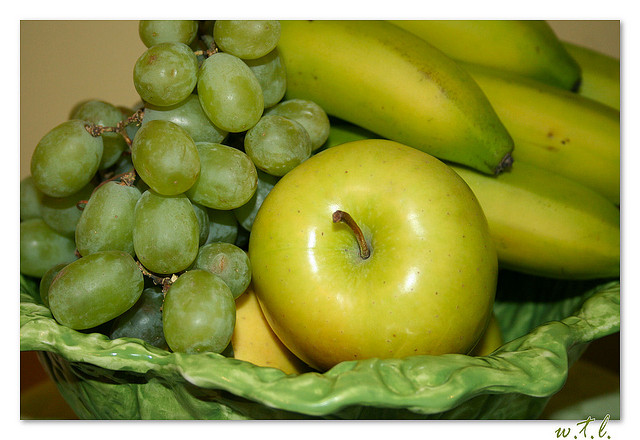<image>Are the strawberries in the bowl ripe? There are no strawberries in the bowl. Are the strawberries in the bowl ripe? I don't know if the strawberries in the bowl are ripe. They can be either ripe or not ripe. 